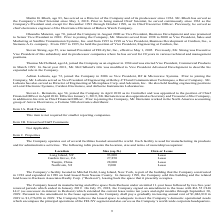From Frequency Electronics's financial document, What is the size of the Long Island, NY and Garden Grove, CA facilities respectively in sq ft? The document shows two values: 93,000 and 27,850. From the document: "ation Size (sq. ft.) Own or Lease Long Island, NY 93,000 Lease Garden Grove, CA 27,850 Lease Tianjin, China 28,000 Lease..." Also, What is the size of the Tianjin, China and Northvale, NJ facilities respectively in sq ft? The document shows two values: 28,000 and 9,000. From the document: "Northvale, NJ 9,000 Lease The Company’s facility located in Mitchel Field, Long Island, New York, is part of the buildi Garden Grove, CA 27,850 Lease ..." Also, When did the company enter into a new lease agreement for its Northvale, New Jersey facility? Based on the financial document, the answer is February 1, 2018. Also, can you calculate: What is the difference in size between the Long Island, NY and Northvale, NJ facility in sq ft? Based on the calculation: 93,000-9,000, the result is 84000. This is based on the information: "Northvale, NJ 9,000 Lease The Company’s facility located in Mitchel Field, Long Island, New York, is part of the buildi ation Size (sq. ft.) Own or Lease Long Island, NY 93,000 Lease..." The key data points involved are: 9,000, 93,000. Also, How many facilities are currently under lease? Counting the relevant items in the document: Long Island, NY ,  Garden Grove, CA ,  Tianjin, China ,  Northvale, NJ, I find 4 instances. The key data points involved are: Garden Grove, CA, Long Island, NY, Northvale, NJ. Also, can you calculate: What is the total size of all the four facilities leased by the company in sq ft? Based on the calculation: 93,000+27,850+28,000+9,000, the result is 157850. This is based on the information: "Northvale, NJ 9,000 Lease The Company’s facility located in Mitchel Field, Long Island, New York, is part of the buildi Garden Grove, CA 27,850 Lease Tianjin, China 28,000 Lease ation Size (sq. ft.) O..." The key data points involved are: 27,850, 28,000, 9,000. 